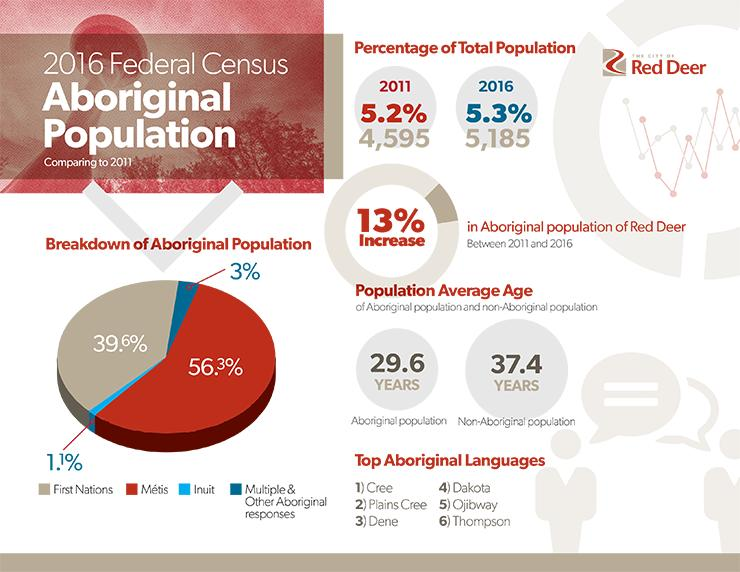Mention a couple of crucial points in this snapshot. The non-Aboriginal population, as reported in the 2016 Federal Census, has an average age of 37.4 years. According to the 2016 Federal Census, only 1.1% of the aboriginal population in Canada is Inuit. In 2016, the First Nations population in Canada accounted for approximately 3.3% of the total population of the country. 